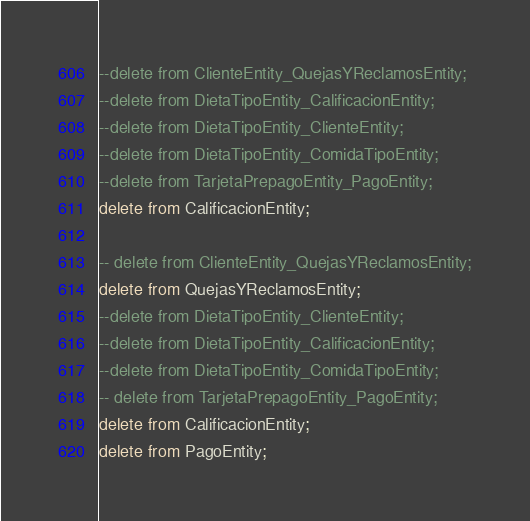<code> <loc_0><loc_0><loc_500><loc_500><_SQL_>

--delete from ClienteEntity_QuejasYReclamosEntity;
--delete from DietaTipoEntity_CalificacionEntity;
--delete from DietaTipoEntity_ClienteEntity;
--delete from DietaTipoEntity_ComidaTipoEntity;
--delete from TarjetaPrepagoEntity_PagoEntity;
delete from CalificacionEntity;

-- delete from ClienteEntity_QuejasYReclamosEntity;
delete from QuejasYReclamosEntity;
--delete from DietaTipoEntity_ClienteEntity;
--delete from DietaTipoEntity_CalificacionEntity;
--delete from DietaTipoEntity_ComidaTipoEntity;
-- delete from TarjetaPrepagoEntity_PagoEntity;
delete from CalificacionEntity;
delete from PagoEntity;</code> 